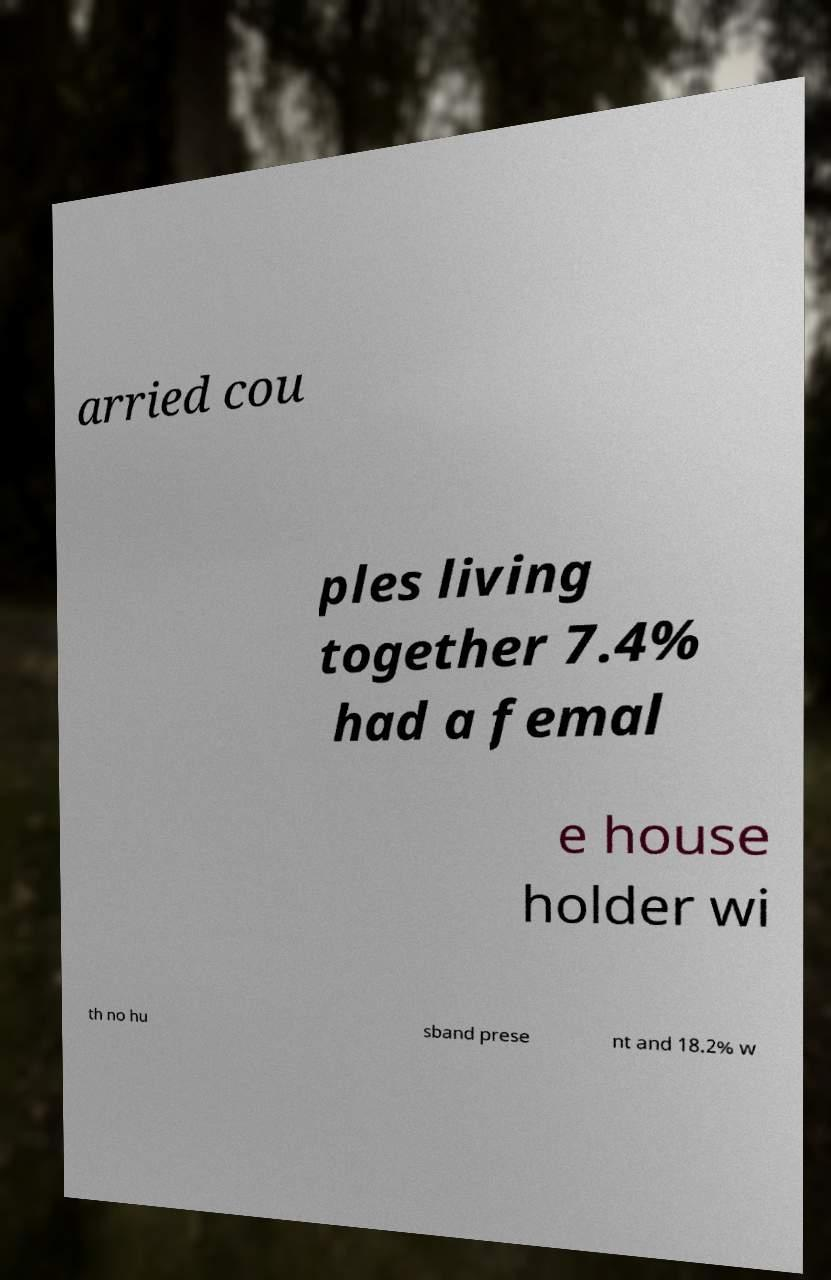Please identify and transcribe the text found in this image. arried cou ples living together 7.4% had a femal e house holder wi th no hu sband prese nt and 18.2% w 